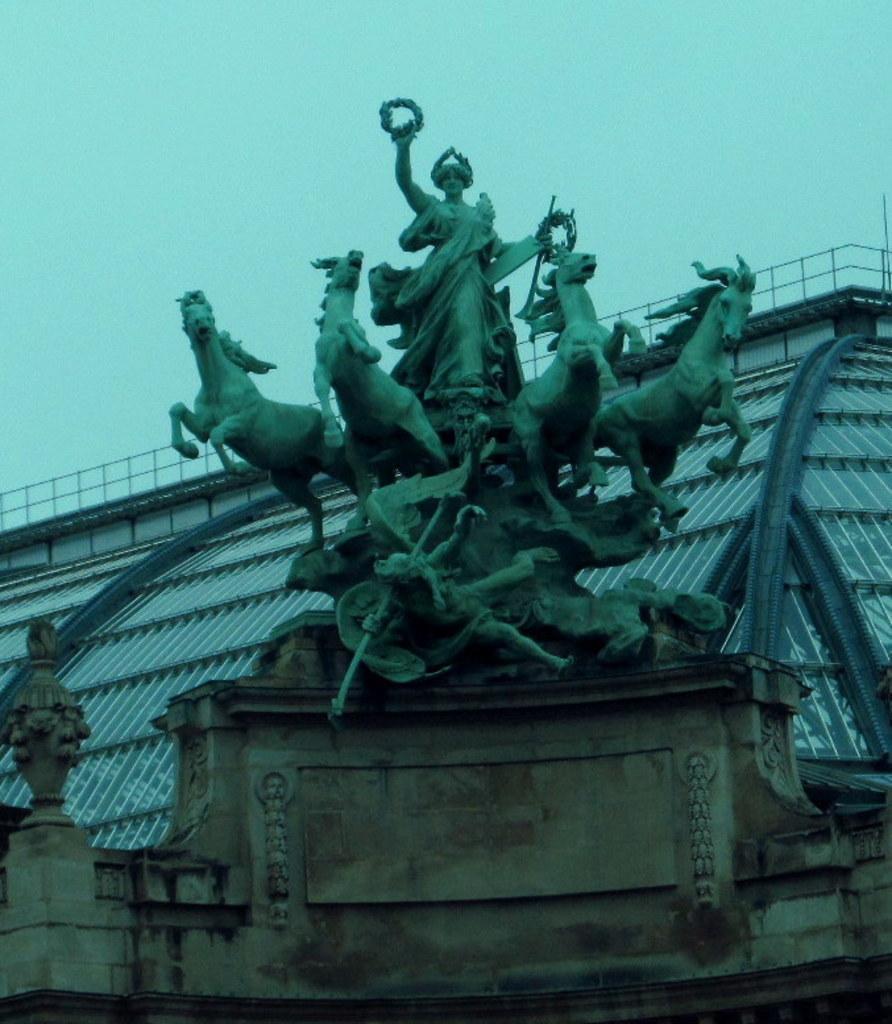Describe this image in one or two sentences. This image is taken outdoors. At the top of the image there is the sky. In the background there is an architecture with many grills. In the middle of the image there are a few sculptures of horses and a woman. At the bottom of the image there is a wall and there are a few carvings on the wall. 